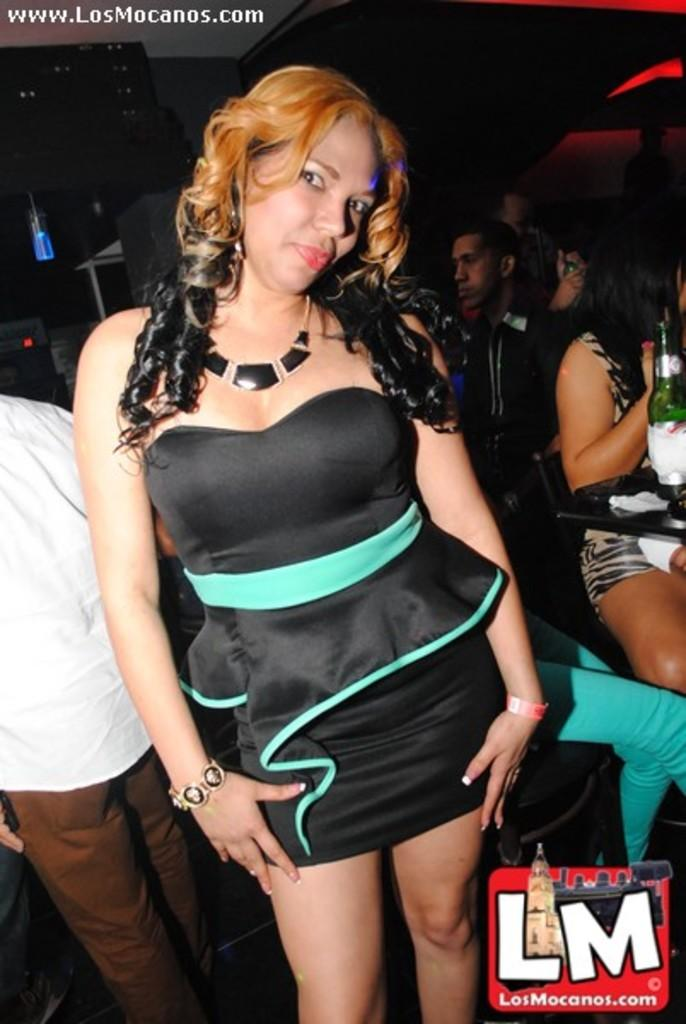<image>
Write a terse but informative summary of the picture. A woman in a short dress is used to advertise the website www.losmocanos.com 